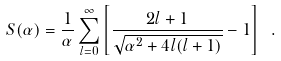<formula> <loc_0><loc_0><loc_500><loc_500>S ( \alpha ) = \frac { 1 } { \alpha } \sum _ { l = 0 } ^ { \infty } \left [ \frac { 2 l + 1 } { \sqrt { \alpha ^ { 2 } + 4 l ( l + 1 ) } } - 1 \right ] \ .</formula> 